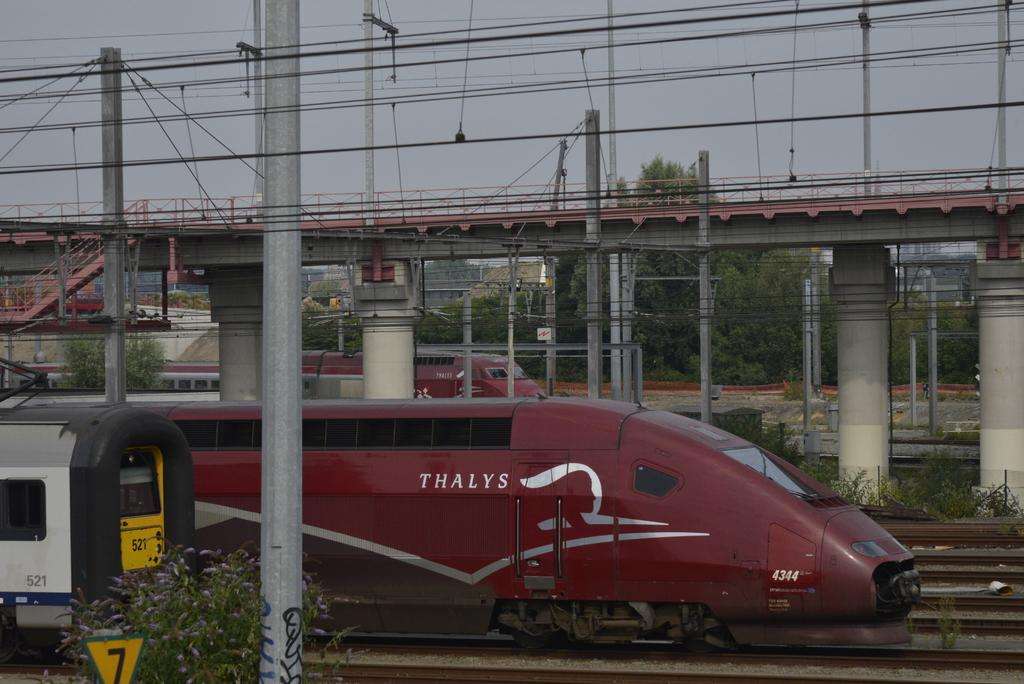<image>
Summarize the visual content of the image. A sleek red train with Thalys in silver on the side. 